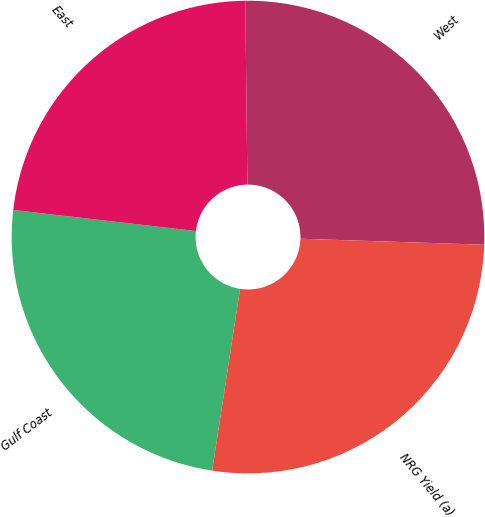Convert chart to OTSL. <chart><loc_0><loc_0><loc_500><loc_500><pie_chart><fcel>Gulf Coast<fcel>East<fcel>West<fcel>NRG Yield (a)<nl><fcel>24.4%<fcel>22.99%<fcel>25.7%<fcel>26.91%<nl></chart> 